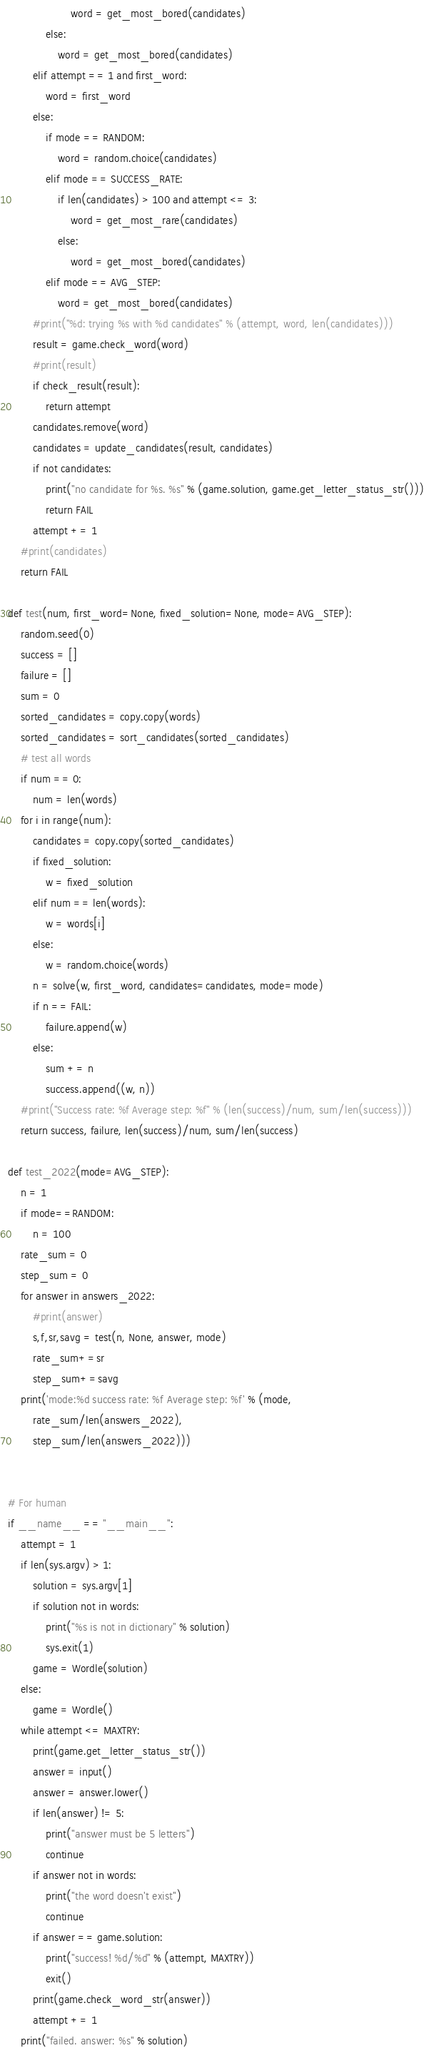Convert code to text. <code><loc_0><loc_0><loc_500><loc_500><_Python_>                    word = get_most_bored(candidates)
            else:
                word = get_most_bored(candidates)
        elif attempt == 1 and first_word:
            word = first_word
        else:
            if mode == RANDOM:
                word = random.choice(candidates)
            elif mode == SUCCESS_RATE:
                if len(candidates) > 100 and attempt <= 3:
                    word = get_most_rare(candidates)
                else:
                    word = get_most_bored(candidates)
            elif mode == AVG_STEP:
                word = get_most_bored(candidates)
        #print("%d: trying %s with %d candidates" % (attempt, word, len(candidates)))
        result = game.check_word(word)
        #print(result)
        if check_result(result):
            return attempt
        candidates.remove(word)
        candidates = update_candidates(result, candidates)
        if not candidates:
            print("no candidate for %s. %s" % (game.solution, game.get_letter_status_str()))
            return FAIL
        attempt += 1
    #print(candidates)
    return FAIL

def test(num, first_word=None, fixed_solution=None, mode=AVG_STEP):
    random.seed(0)
    success = []
    failure = []
    sum = 0
    sorted_candidates = copy.copy(words)
    sorted_candidates = sort_candidates(sorted_candidates)
    # test all words
    if num == 0:
        num = len(words)
    for i in range(num):
        candidates = copy.copy(sorted_candidates)
        if fixed_solution:
            w = fixed_solution
        elif num == len(words):
            w = words[i]
        else:
            w = random.choice(words)
        n = solve(w, first_word, candidates=candidates, mode=mode)
        if n == FAIL:
            failure.append(w)
        else:
            sum += n
            success.append((w, n))
    #print("Success rate: %f Average step: %f" % (len(success)/num, sum/len(success)))
    return success, failure, len(success)/num, sum/len(success)

def test_2022(mode=AVG_STEP):
    n = 1
    if mode==RANDOM:
        n = 100
    rate_sum = 0
    step_sum = 0
    for answer in answers_2022:
        #print(answer)
        s,f,sr,savg = test(n, None, answer, mode)
        rate_sum+=sr
        step_sum+=savg
    print('mode:%d success rate: %f Average step: %f' % (mode,
        rate_sum/len(answers_2022),
        step_sum/len(answers_2022)))
        

# For human 
if __name__ == "__main__":
    attempt = 1
    if len(sys.argv) > 1:
        solution = sys.argv[1]
        if solution not in words:
            print("%s is not in dictionary" % solution)
            sys.exit(1)
        game = Wordle(solution)
    else:
        game = Wordle()
    while attempt <= MAXTRY:
        print(game.get_letter_status_str())
        answer = input()
        answer = answer.lower()
        if len(answer) != 5:
            print("answer must be 5 letters")
            continue
        if answer not in words:
            print("the word doesn't exist")
            continue
        if answer == game.solution:
            print("success! %d/%d" % (attempt, MAXTRY))
            exit()
        print(game.check_word_str(answer))
        attempt += 1
    print("failed. answer: %s" % solution)
</code> 